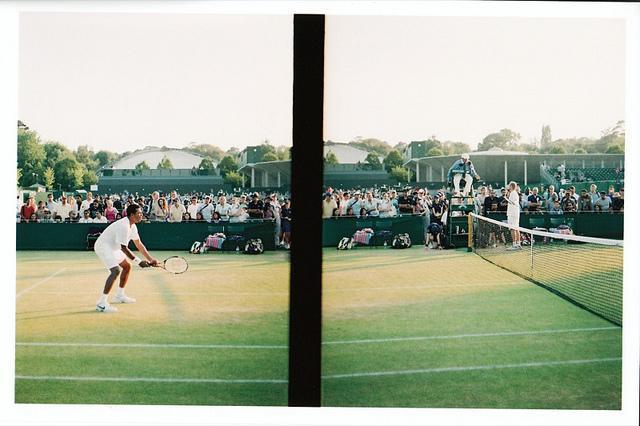Who is the person sitting high above the tennis net?
Choose the correct response, then elucidate: 'Answer: answer
Rationale: rationale.'
Options: Referee, trainer, coach, announcer. Answer: referee.
Rationale: A referee judges plays from the high seat. 